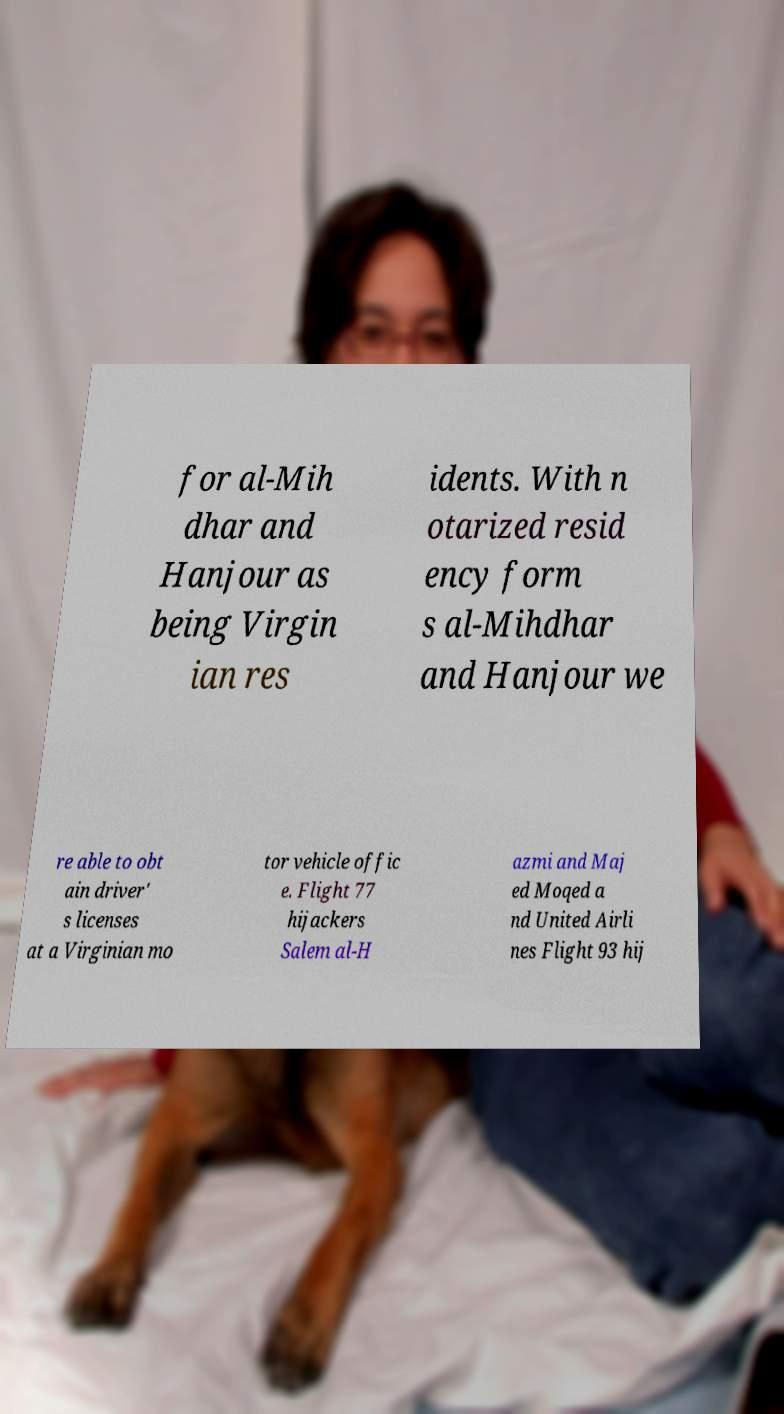Please read and relay the text visible in this image. What does it say? for al-Mih dhar and Hanjour as being Virgin ian res idents. With n otarized resid ency form s al-Mihdhar and Hanjour we re able to obt ain driver' s licenses at a Virginian mo tor vehicle offic e. Flight 77 hijackers Salem al-H azmi and Maj ed Moqed a nd United Airli nes Flight 93 hij 